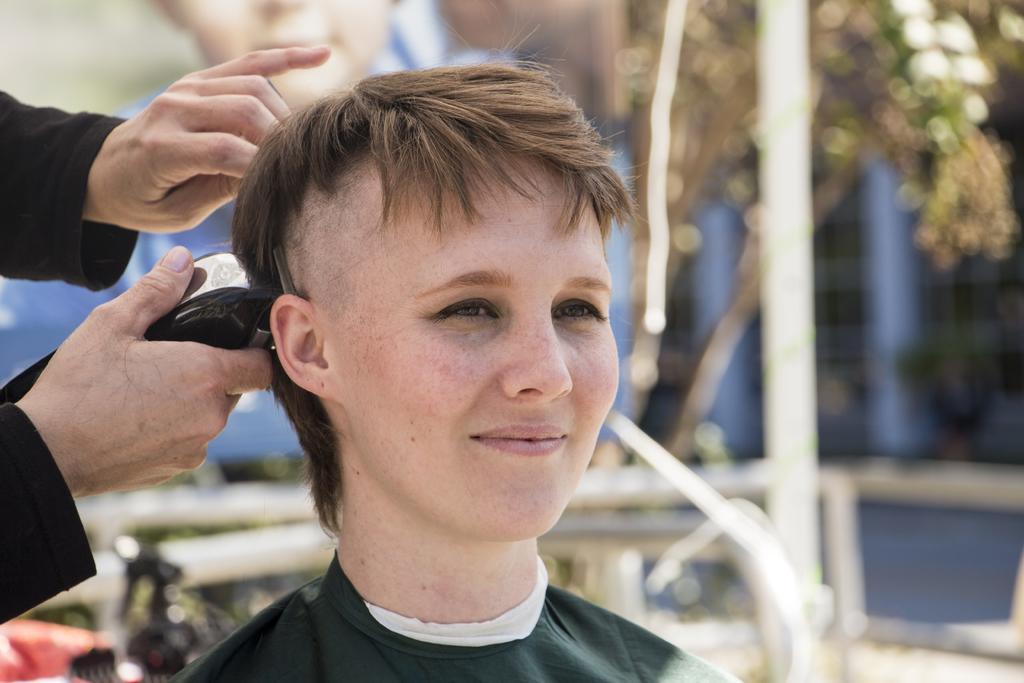Describe this image in one or two sentences. In the foreground of the picture there is a woman. On the left there is a person holding trimmer. In the background there are trees, poles and other objects. 